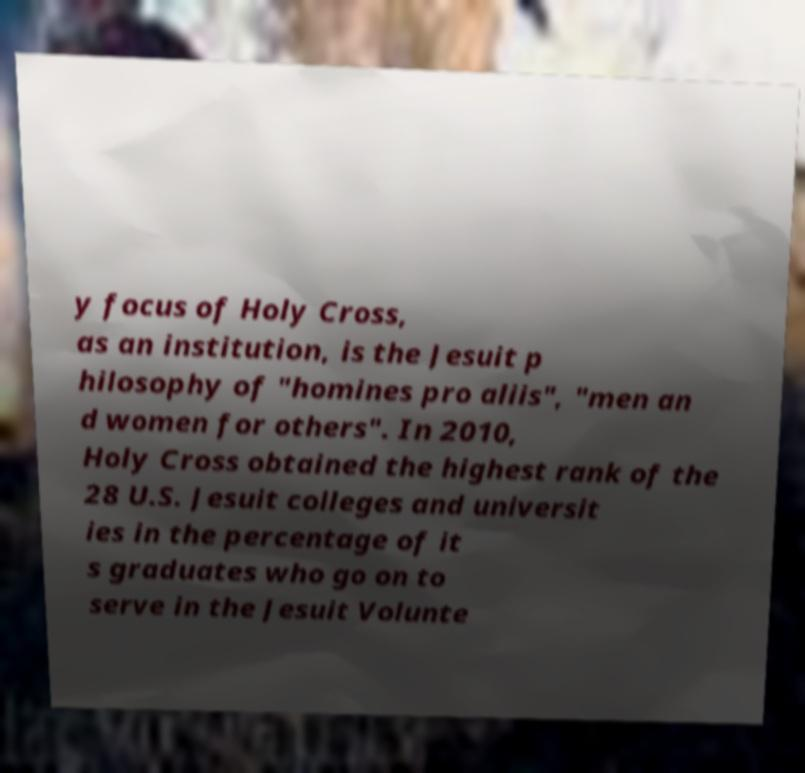Could you assist in decoding the text presented in this image and type it out clearly? y focus of Holy Cross, as an institution, is the Jesuit p hilosophy of "homines pro aliis", "men an d women for others". In 2010, Holy Cross obtained the highest rank of the 28 U.S. Jesuit colleges and universit ies in the percentage of it s graduates who go on to serve in the Jesuit Volunte 